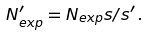<formula> <loc_0><loc_0><loc_500><loc_500>N ^ { \prime } _ { e x p } = N _ { e x p } s / s ^ { \prime } \, .</formula> 